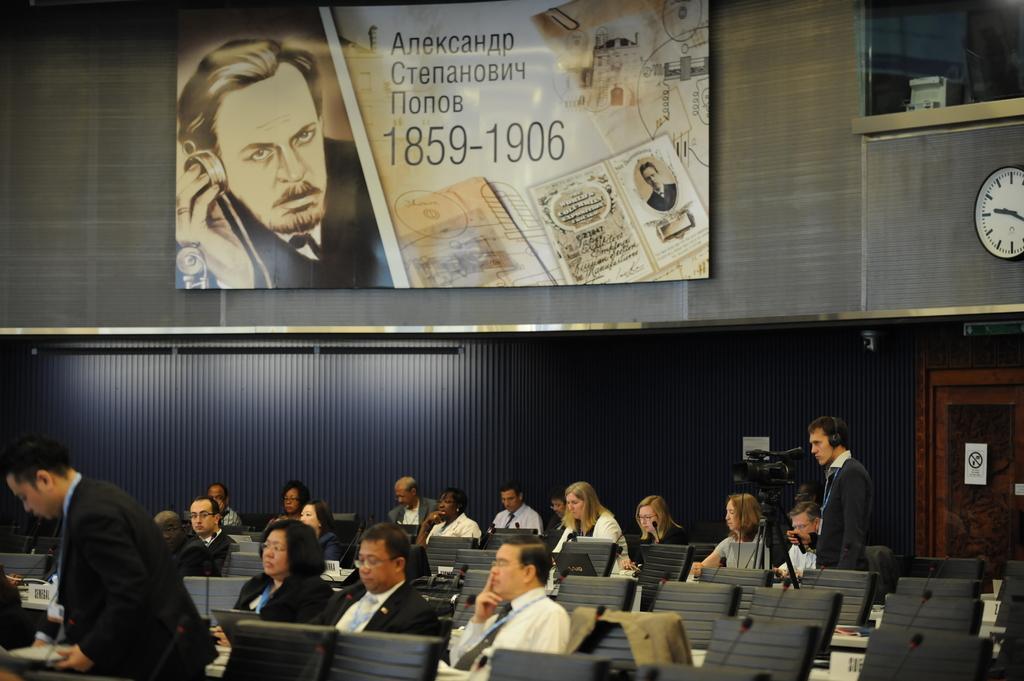Could you give a brief overview of what you see in this image? In this picture I can see many people were sitting on the chair near to the table. On the table I can see the papers, bag, purse and other objects. At the top I can see the banner which is placed on the wall. In the top right corner there is a window, besides that I can see the wall clock. On the right there is a man who is standing near to the camera. Behind him I can see the door. 